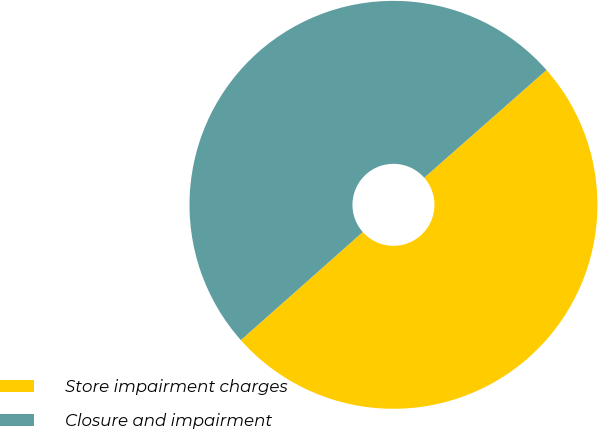Convert chart. <chart><loc_0><loc_0><loc_500><loc_500><pie_chart><fcel>Store impairment charges<fcel>Closure and impairment<nl><fcel>49.95%<fcel>50.05%<nl></chart> 